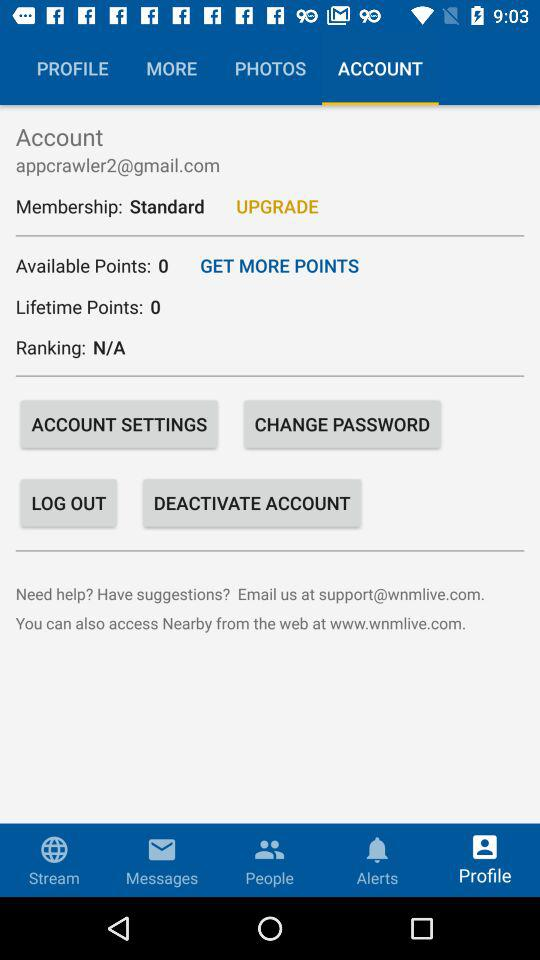How is the membership? The membership is "Standard". 